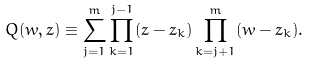<formula> <loc_0><loc_0><loc_500><loc_500>Q ( w , z ) \equiv \sum _ { j = 1 } ^ { m } \prod _ { k = 1 } ^ { j - 1 } ( z - z _ { k } ) \prod _ { k = j + 1 } ^ { m } ( w - z _ { k } ) .</formula> 